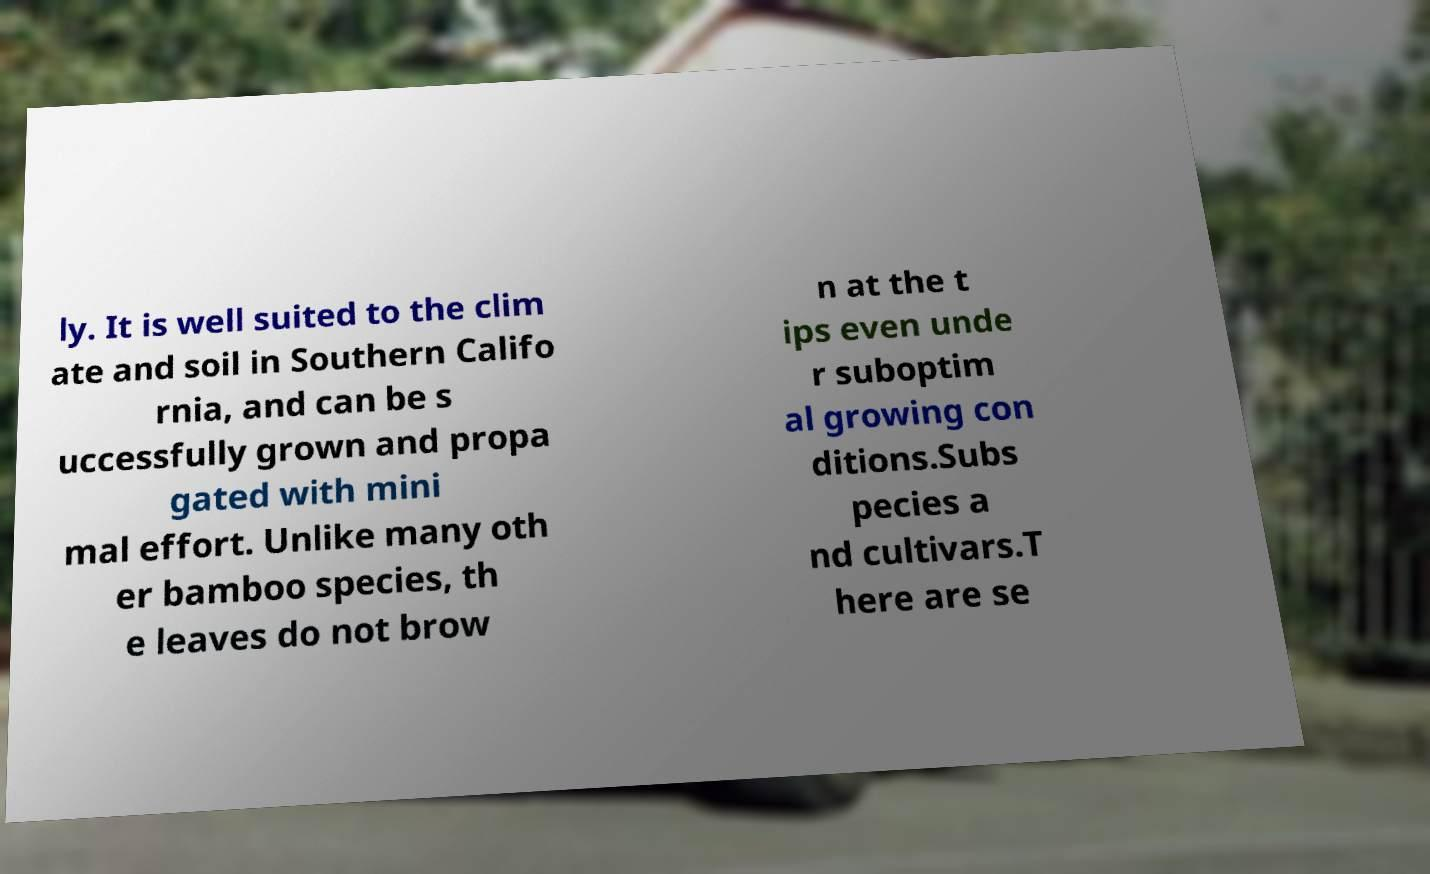Please identify and transcribe the text found in this image. ly. It is well suited to the clim ate and soil in Southern Califo rnia, and can be s uccessfully grown and propa gated with mini mal effort. Unlike many oth er bamboo species, th e leaves do not brow n at the t ips even unde r suboptim al growing con ditions.Subs pecies a nd cultivars.T here are se 